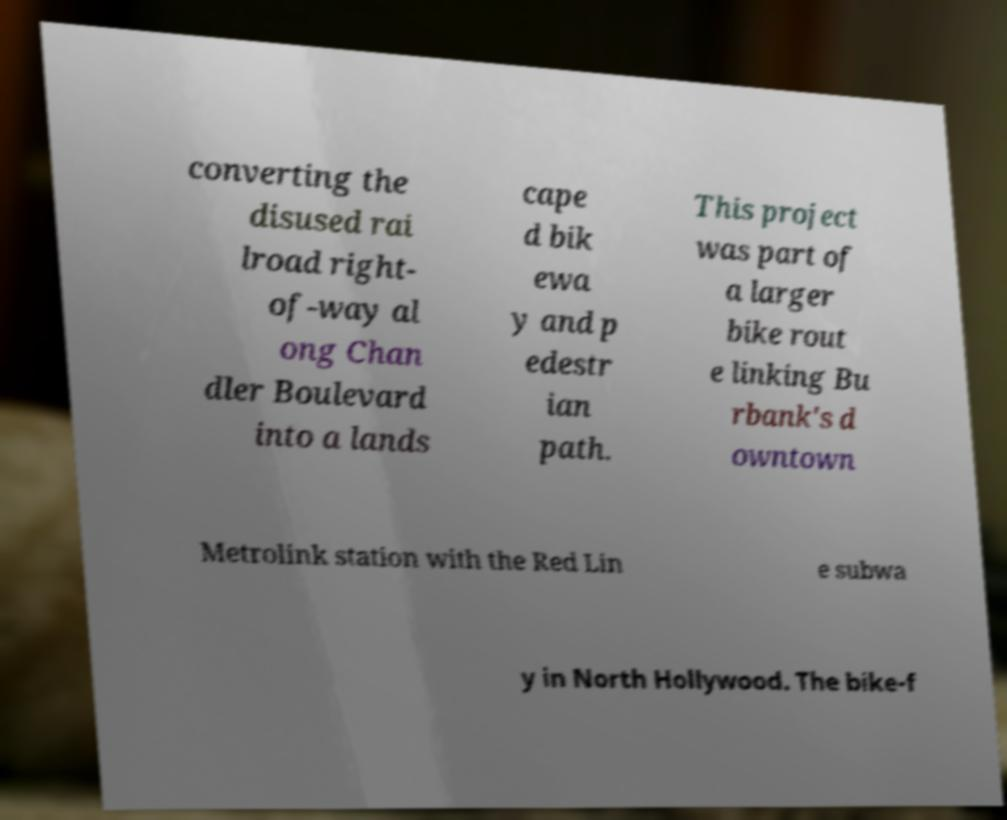Please identify and transcribe the text found in this image. converting the disused rai lroad right- of-way al ong Chan dler Boulevard into a lands cape d bik ewa y and p edestr ian path. This project was part of a larger bike rout e linking Bu rbank's d owntown Metrolink station with the Red Lin e subwa y in North Hollywood. The bike-f 